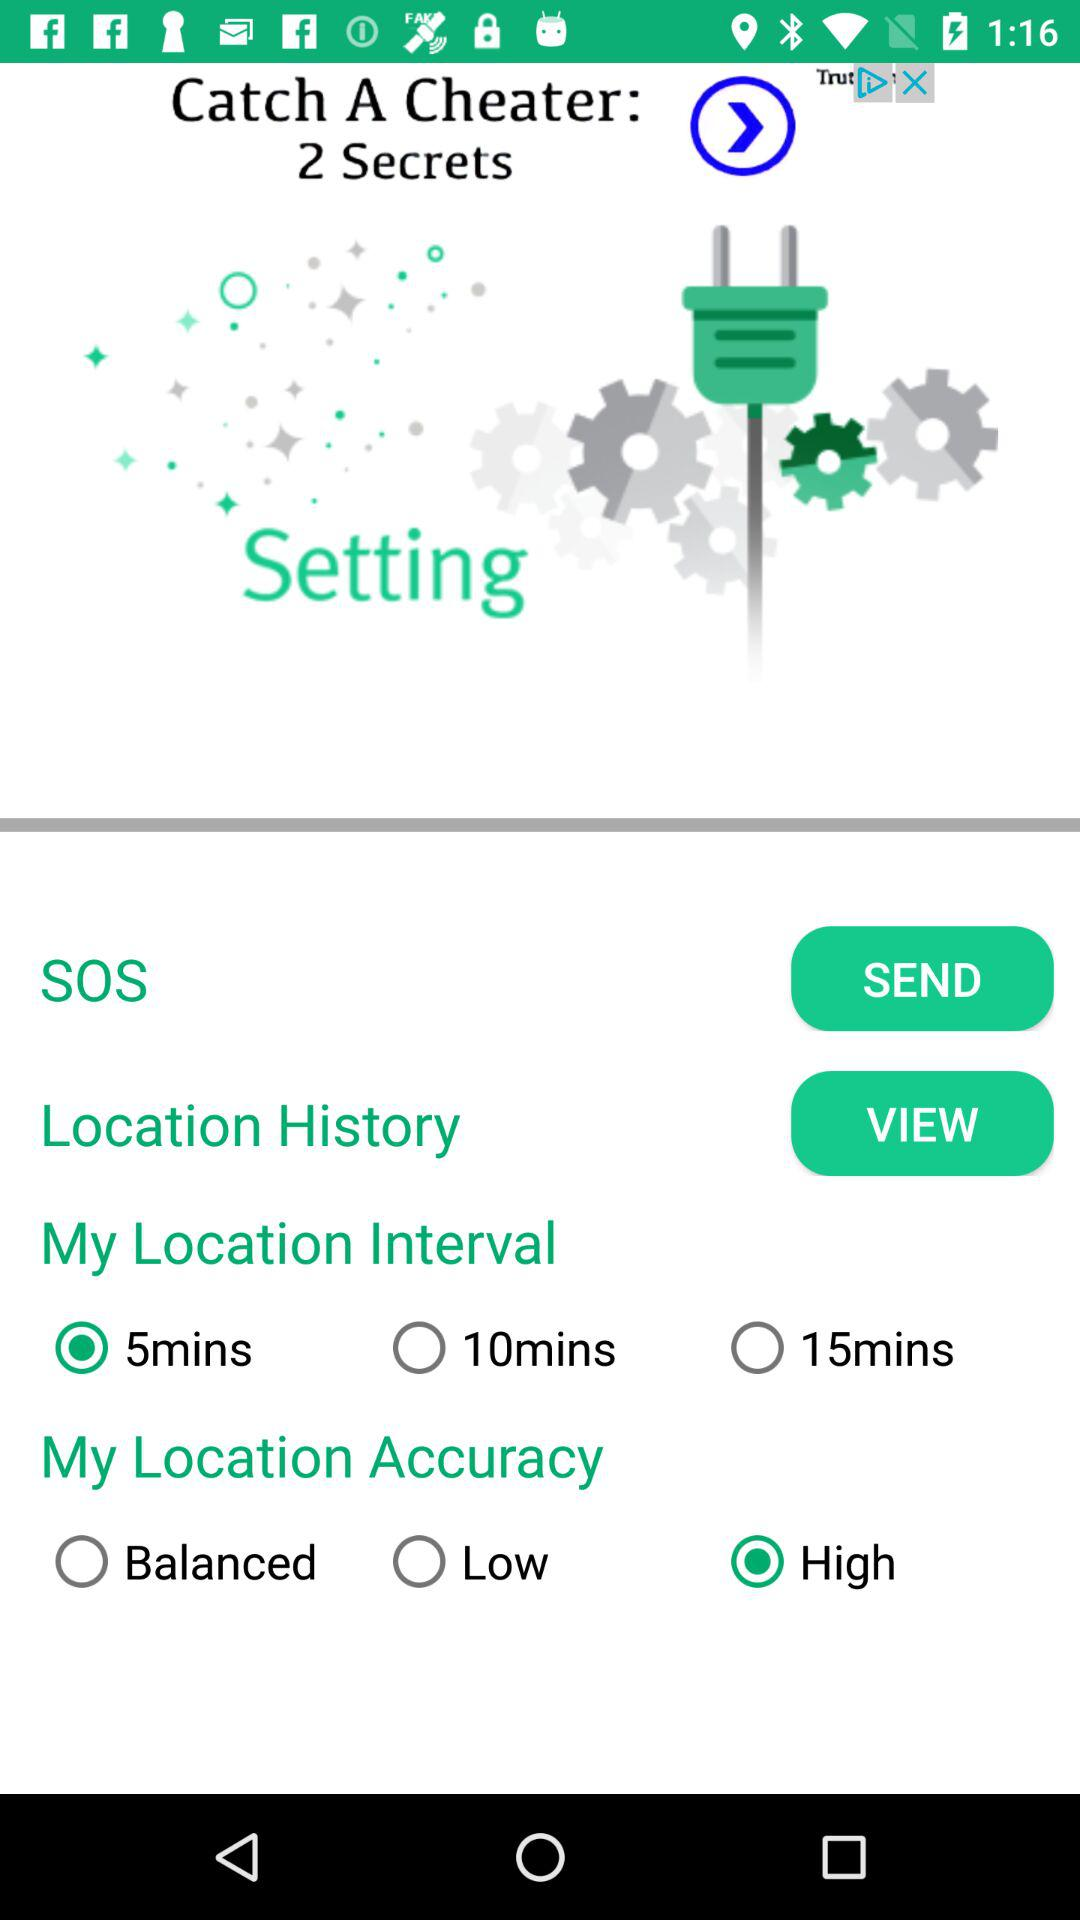Is "15mins" selected or not in "My Location Interval"? The "15mins" is not selected in "My Location Interval". 